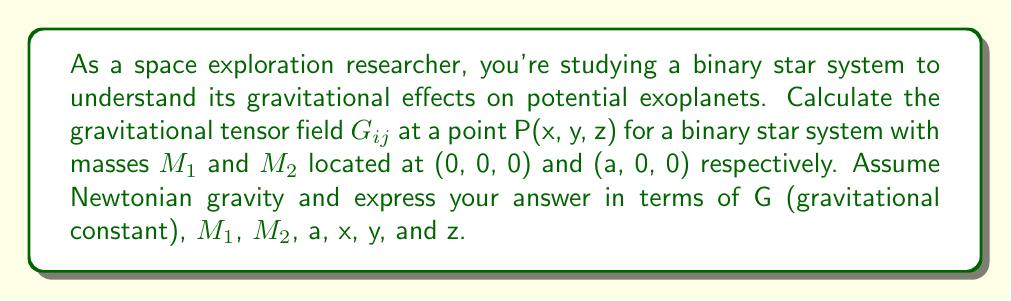Give your solution to this math problem. 1. The gravitational potential $\Phi$ for the binary star system is given by:

   $$\Phi = -G\left(\frac{M_1}{r_1} + \frac{M_2}{r_2}\right)$$

   where $r_1 = \sqrt{x^2 + y^2 + z^2}$ and $r_2 = \sqrt{(x-a)^2 + y^2 + z^2}$

2. The gravitational tensor field $G_{ij}$ is defined as:

   $$G_{ij} = \frac{\partial^2 \Phi}{\partial x_i \partial x_j} + \delta_{ij}\nabla^2\Phi$$

3. Calculate the second derivatives:

   $$\frac{\partial^2 \Phi}{\partial x^2} = G\left(\frac{M_1}{r_1^3}(3x^2 - r_1^2) + \frac{M_2}{r_2^3}(3(x-a)^2 - r_2^2)\right)$$
   
   $$\frac{\partial^2 \Phi}{\partial y^2} = G\left(\frac{M_1}{r_1^3}(3y^2 - r_1^2) + \frac{M_2}{r_2^3}(3y^2 - r_2^2)\right)$$
   
   $$\frac{\partial^2 \Phi}{\partial z^2} = G\left(\frac{M_1}{r_1^3}(3z^2 - r_1^2) + \frac{M_2}{r_2^3}(3z^2 - r_2^2)\right)$$
   
   $$\frac{\partial^2 \Phi}{\partial x\partial y} = \frac{\partial^2 \Phi}{\partial y\partial x} = G\left(\frac{3M_1xy}{r_1^5} + \frac{3M_2(x-a)y}{r_2^5}\right)$$
   
   $$\frac{\partial^2 \Phi}{\partial x\partial z} = \frac{\partial^2 \Phi}{\partial z\partial x} = G\left(\frac{3M_1xz}{r_1^5} + \frac{3M_2(x-a)z}{r_2^5}\right)$$
   
   $$\frac{\partial^2 \Phi}{\partial y\partial z} = \frac{\partial^2 \Phi}{\partial z\partial y} = G\left(\frac{3M_1yz}{r_1^5} + \frac{3M_2yz}{r_2^5}\right)$$

4. Calculate $\nabla^2\Phi$:

   $$\nabla^2\Phi = \frac{\partial^2 \Phi}{\partial x^2} + \frac{\partial^2 \Phi}{\partial y^2} + \frac{\partial^2 \Phi}{\partial z^2} = 0$$

5. Construct the gravitational tensor field $G_{ij}$:

   $$G_{ij} = G\begin{pmatrix}
   \frac{M_1}{r_1^3}(3x^2 - r_1^2) + \frac{M_2}{r_2^3}(3(x-a)^2 - r_2^2) & \frac{3M_1xy}{r_1^5} + \frac{3M_2(x-a)y}{r_2^5} & \frac{3M_1xz}{r_1^5} + \frac{3M_2(x-a)z}{r_2^5} \\
   \frac{3M_1xy}{r_1^5} + \frac{3M_2(x-a)y}{r_2^5} & \frac{M_1}{r_1^3}(3y^2 - r_1^2) + \frac{M_2}{r_2^3}(3y^2 - r_2^2) & \frac{3M_1yz}{r_1^5} + \frac{3M_2yz}{r_2^5} \\
   \frac{3M_1xz}{r_1^5} + \frac{3M_2(x-a)z}{r_2^5} & \frac{3M_1yz}{r_1^5} + \frac{3M_2yz}{r_2^5} & \frac{M_1}{r_1^3}(3z^2 - r_1^2) + \frac{M_2}{r_2^3}(3z^2 - r_2^2)
   \end{pmatrix}$$
Answer: $$G_{ij} = G\begin{pmatrix}
\frac{M_1}{r_1^3}(3x^2 - r_1^2) + \frac{M_2}{r_2^3}(3(x-a)^2 - r_2^2) & \frac{3M_1xy}{r_1^5} + \frac{3M_2(x-a)y}{r_2^5} & \frac{3M_1xz}{r_1^5} + \frac{3M_2(x-a)z}{r_2^5} \\
\frac{3M_1xy}{r_1^5} + \frac{3M_2(x-a)y}{r_2^5} & \frac{M_1}{r_1^3}(3y^2 - r_1^2) + \frac{M_2}{r_2^3}(3y^2 - r_2^2) & \frac{3M_1yz}{r_1^5} + \frac{3M_2yz}{r_2^5} \\
\frac{3M_1xz}{r_1^5} + \frac{3M_2(x-a)z}{r_2^5} & \frac{3M_1yz}{r_1^5} + \frac{3M_2yz}{r_2^5} & \frac{M_1}{r_1^3}(3z^2 - r_1^2) + \frac{M_2}{r_2^3}(3z^2 - r_2^2)
\end{pmatrix}$$ 